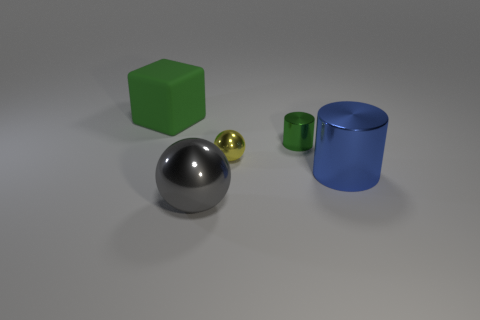How many other objects are the same size as the yellow thing?
Make the answer very short. 1. What color is the big block?
Make the answer very short. Green. How many large objects are blocks or red cylinders?
Your answer should be very brief. 1. Do the sphere left of the small yellow object and the shiny ball behind the gray sphere have the same size?
Provide a succinct answer. No. The gray object that is the same shape as the tiny yellow metallic object is what size?
Ensure brevity in your answer.  Large. Are there more green metallic objects that are left of the yellow ball than big blue cylinders that are behind the big matte block?
Give a very brief answer. No. The big object that is to the left of the green metal cylinder and in front of the small shiny cylinder is made of what material?
Offer a terse response. Metal. What color is the other tiny thing that is the same shape as the blue thing?
Offer a terse response. Green. How big is the rubber object?
Your answer should be very brief. Large. What color is the big shiny object in front of the object that is to the right of the small green metal cylinder?
Provide a short and direct response. Gray. 